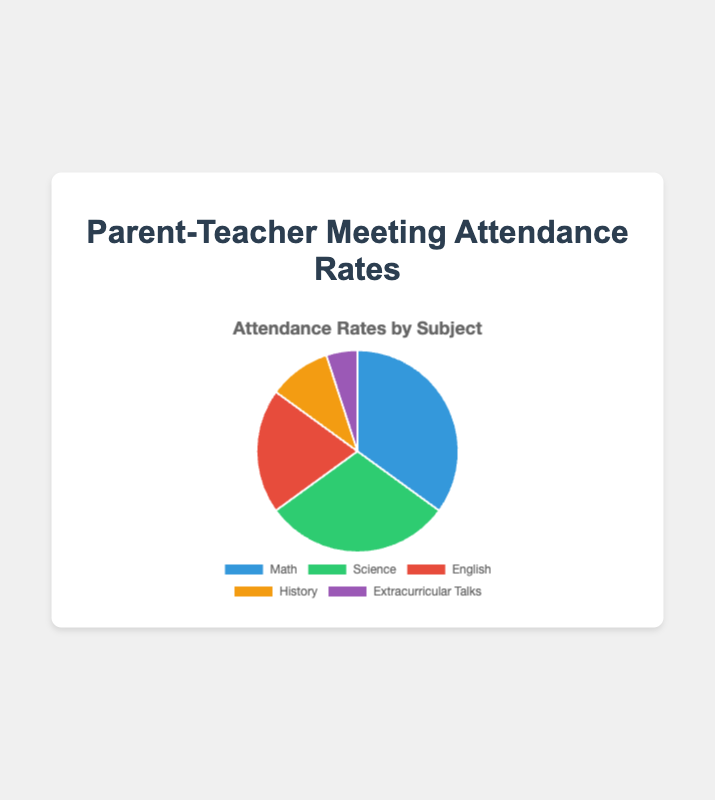What is the attendance rate for Science? According to the pie chart, the segment representing Science shows an attendance rate of 30%.
Answer: 30% Which subject has the lowest attendance rate? The pie chart segment labeled 'Extracurricular Talks' is the smallest, representing the lowest attendance rate of 5%.
Answer: Extracurricular Talks How much higher is the attendance rate for Math compared to English? To find the difference, subtract the attendance rate for English (20%) from the attendance rate for Math (35%): 35% - 20% = 15%.
Answer: 15% What percentage of the attendance rates is for non-academic subjects (Extracurricular Talks)? The attendance rate for Extracurricular Talks is directly given in the chart as 5%.
Answer: 5% Which subject has the second-highest attendance rate? The chart shows that Math has the highest attendance rate at 35%, and the next largest segment is Science with a 30% attendance rate.
Answer: Science How much do the attendance rates for Math and Science combined sum up to? Add the attendance rates for Math (35%) and Science (30%): 35% + 30% = 65%.
Answer: 65% What is the average attendance rate across all subjects? To find the average, sum up the attendance rates (35% + 30% + 20% + 10% + 5% = 100%) and divide by the number of subjects (5): 100% / 5 = 20%.
Answer: 20% By how much does the attendance rate for History exceed that for Extracurricular Talks? Subtract the attendance rate for Extracurricular Talks (5%) from that of History (10%): 10% - 5% = 5%.
Answer: 5% Which two subjects have a combined attendance rate equal to that of Math? The attendance rates for Science (30%) and English (20%) together sum up to 50%. The math attendance rate of 35% is unique, but lower individual rates don't add up exactly to it. Clearly, Science and English dominate the other combinations.
Answer: None 